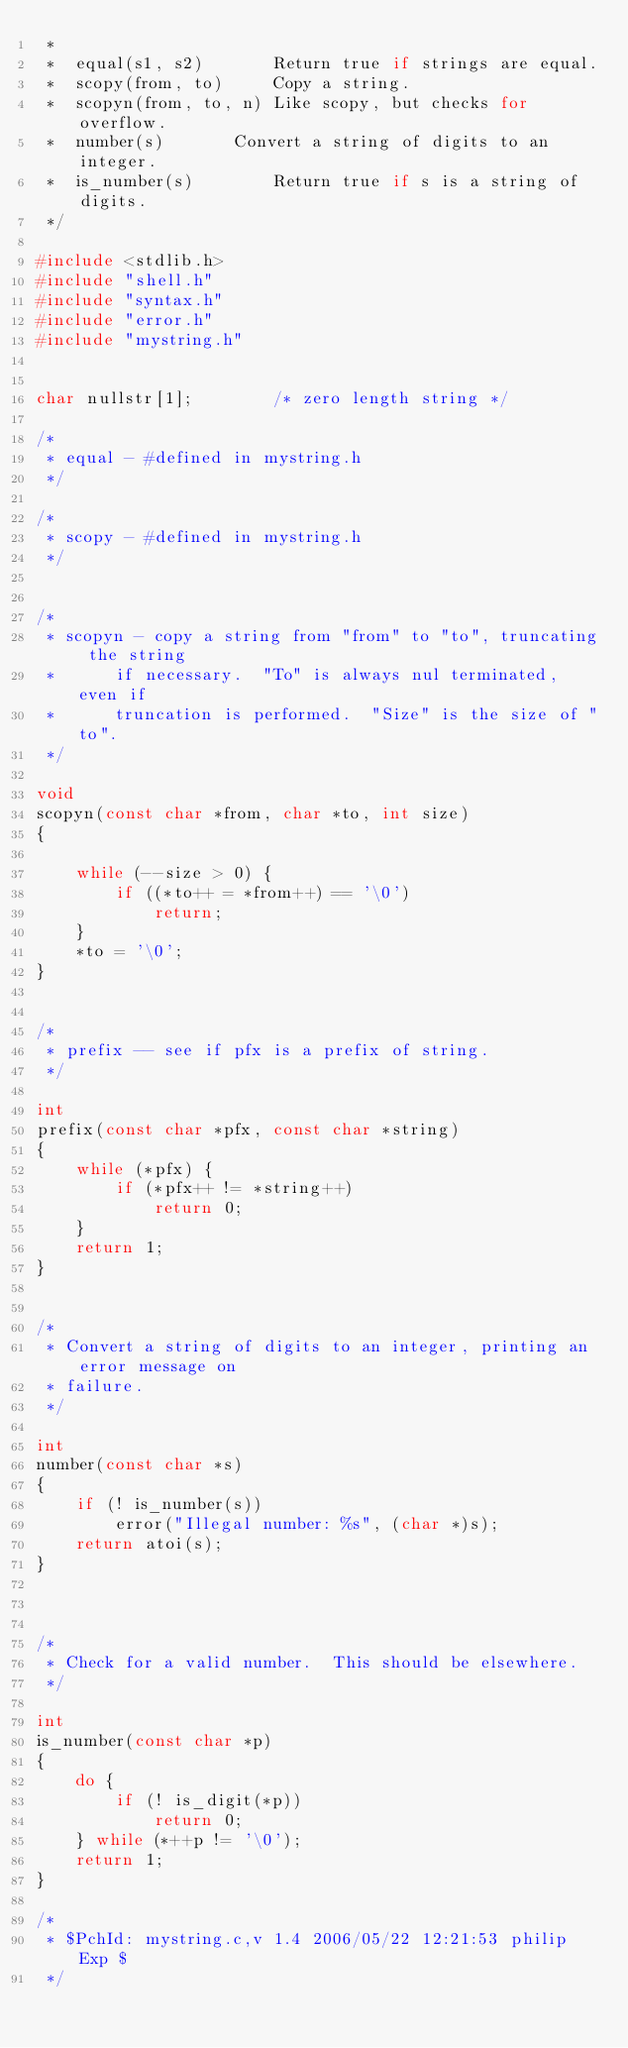Convert code to text. <code><loc_0><loc_0><loc_500><loc_500><_C_> *
 *	equal(s1, s2)		Return true if strings are equal.
 *	scopy(from, to)		Copy a string.
 *	scopyn(from, to, n)	Like scopy, but checks for overflow.
 *	number(s)		Convert a string of digits to an integer.
 *	is_number(s)		Return true if s is a string of digits.
 */

#include <stdlib.h>
#include "shell.h"
#include "syntax.h"
#include "error.h"
#include "mystring.h"


char nullstr[1];		/* zero length string */

/*
 * equal - #defined in mystring.h
 */

/*
 * scopy - #defined in mystring.h
 */


/*
 * scopyn - copy a string from "from" to "to", truncating the string
 *		if necessary.  "To" is always nul terminated, even if
 *		truncation is performed.  "Size" is the size of "to".
 */

void
scopyn(const char *from, char *to, int size)
{

	while (--size > 0) {
		if ((*to++ = *from++) == '\0')
			return;
	}
	*to = '\0';
}


/*
 * prefix -- see if pfx is a prefix of string.
 */

int
prefix(const char *pfx, const char *string)
{
	while (*pfx) {
		if (*pfx++ != *string++)
			return 0;
	}
	return 1;
}


/*
 * Convert a string of digits to an integer, printing an error message on
 * failure.
 */

int
number(const char *s)
{
	if (! is_number(s))
		error("Illegal number: %s", (char *)s);
	return atoi(s);
}



/*
 * Check for a valid number.  This should be elsewhere.
 */

int
is_number(const char *p)
{
	do {
		if (! is_digit(*p))
			return 0;
	} while (*++p != '\0');
	return 1;
}

/*
 * $PchId: mystring.c,v 1.4 2006/05/22 12:21:53 philip Exp $
 */
</code> 